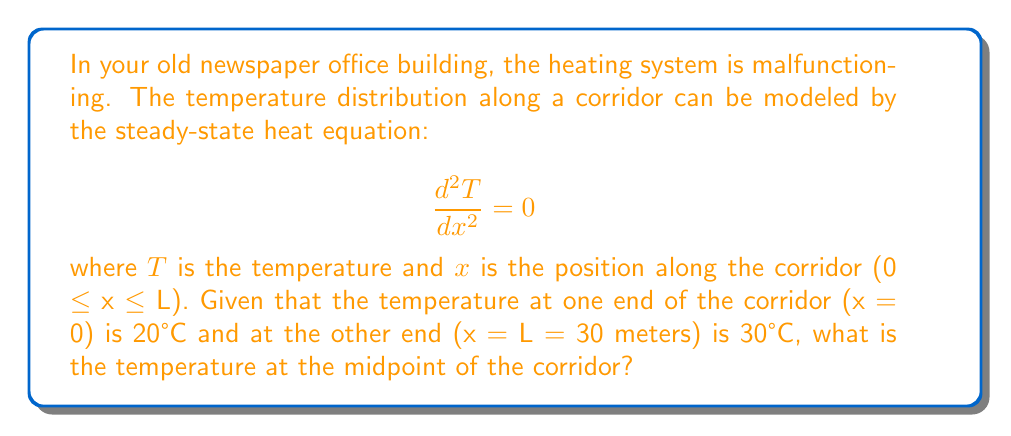Show me your answer to this math problem. Let's solve this step-by-step:

1) The general solution to the steady-state heat equation $\frac{d^2T}{dx^2} = 0$ is:

   $$T(x) = Ax + B$$

   where A and B are constants we need to determine.

2) We have two boundary conditions:
   At x = 0, T = 20°C
   At x = L = 30m, T = 30°C

3) Let's apply the first boundary condition:
   $$20 = A(0) + B$$
   $$B = 20$$

4) Now, let's apply the second boundary condition:
   $$30 = A(30) + 20$$
   $$10 = 30A$$
   $$A = \frac{1}{3}$$

5) Therefore, our temperature distribution function is:
   $$T(x) = \frac{1}{3}x + 20$$

6) To find the temperature at the midpoint, we need to calculate T(L/2):
   $$T(15) = \frac{1}{3}(15) + 20 = 5 + 20 = 25$$

Thus, the temperature at the midpoint of the corridor is 25°C.
Answer: 25°C 